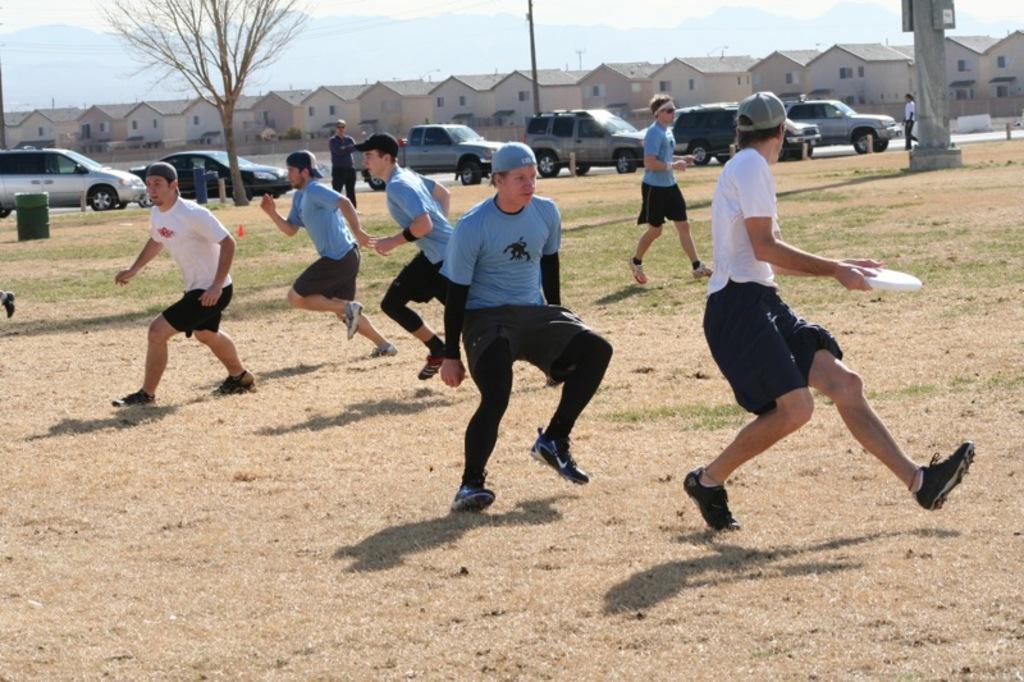How would you summarize this image in a sentence or two? In this picture we can see some people on the ground and a man holding a Frisbee with his hands and a person standing and in the background we can see the grass, vehicles, tree, poles, buildings with windows and some objects and the sky. 